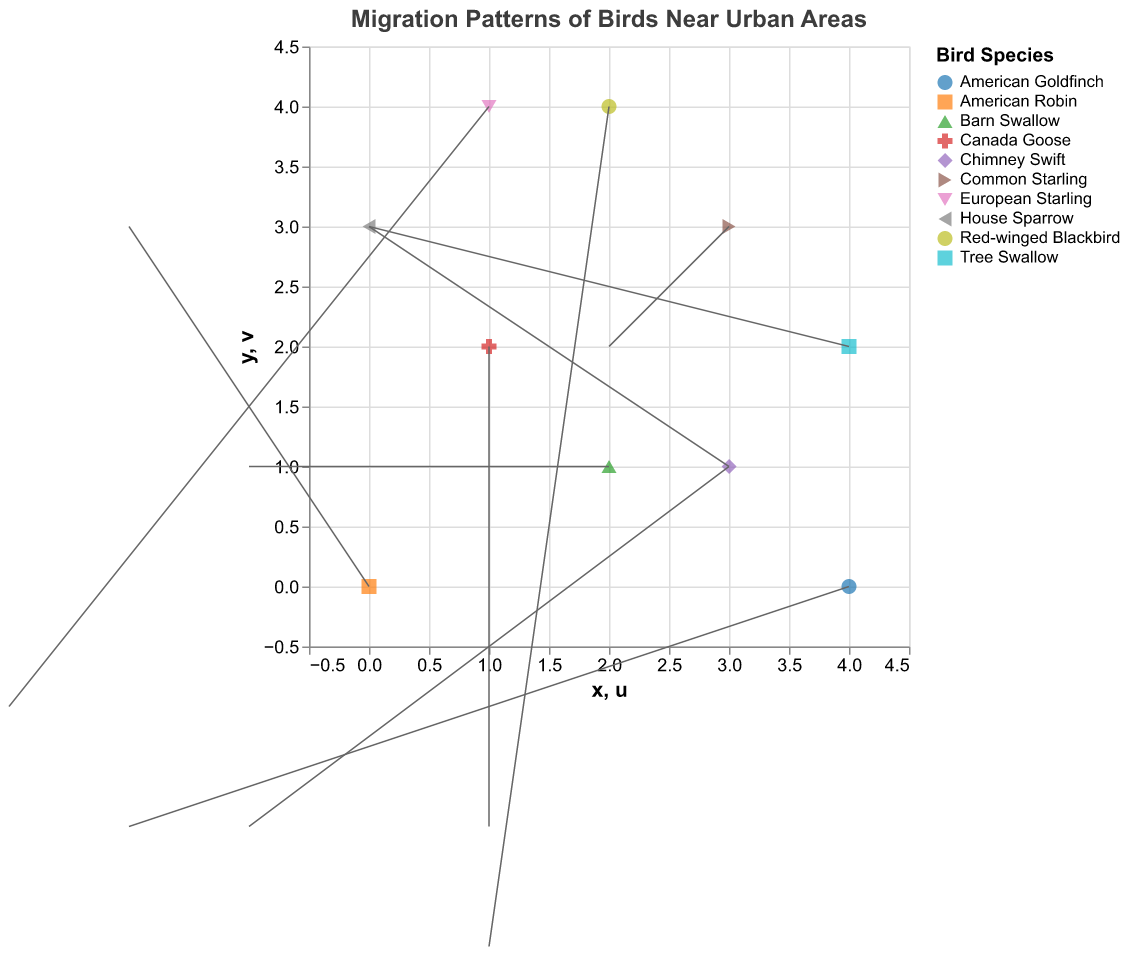How many data points are there in the plot? There are 10 data points listed in the code, each representing a different bird species. Each data point corresponds to one set of (x, y) coordinates with associated (u, v) directions.
Answer: 10 Which bird species is represented at the position (3,3)? The data point at position (3,3) is linked to the species "Common Starling" as indicated in the data.
Answer: Common Starling What direction and intensity does the American Robin show at its position? The "u" and "v" values for the American Robin are -2 and 3, respectively. The direction is represented by the (u, v) vector originating from (0, 0). The intensity can be qualitatively inferred as moderate.
Answer: Direction: (-2, 3) Which species shows the largest movement in either the x or y direction? To find the largest movement, we compare the absolute values of u and v for each species. The Tree Swallow has a movement of 3 in the y direction, which seems to be the largest along with the House Sparrow which also moves 3 in the x direction. However, the Common Starling shows movement of (2, 2), distributed equally but not exceeding 3 in a single direction.
Answer: Tree Swallow or House Sparrow How many species exhibit movement to the left (negative x direction)? By looking at the data points with negative "u" values: American Robin, Barn Swallow, European Starling, American Goldfinch, and Chimney Swift, we count five species moving to the left.
Answer: 5 Which bird species is migrating directly upwards (positive y direction) without any horizontal movement? Only the Tree Swallow has u=0 and v=3, indicating it is moving straight up.
Answer: Tree Swallow What is the overall migration trend for the House Sparrow? The House Sparrow has values u=3 and v=1. This means it trends mostly to the right and slightly upward.
Answer: Mostly right, slightly upward Which species has its direction vector pointing downwards both in the x and y directions? The species with negative values for both u and v components are the Canada Goose and Chimney Swift, indicating downward movement.
Answer: Canada Goose, Chimney Swift What is the combined y-direction movement of the American Robin and the Common Starling? For the American Robin, v=3 and for the Common Starling, v=2. So the combined y-direction movement is 3 + 2.
Answer: 5 Compare the movements of the Canada Goose and Barn Swallow. Which one has a greater overall movement intensity? The Canada Goose has a directional vector of (1, -2) while the Barn Swallow has a vector of (-1, 1). Calculating the magnitudes: Canada Goose: sqrt(1^2 + (-2)^2) = sqrt(5); Barn Swallow: sqrt((-1)^2 + 1^2) = sqrt(2). Hence, the Canada Goose has greater overall movement intensity.
Answer: Canada Goose 